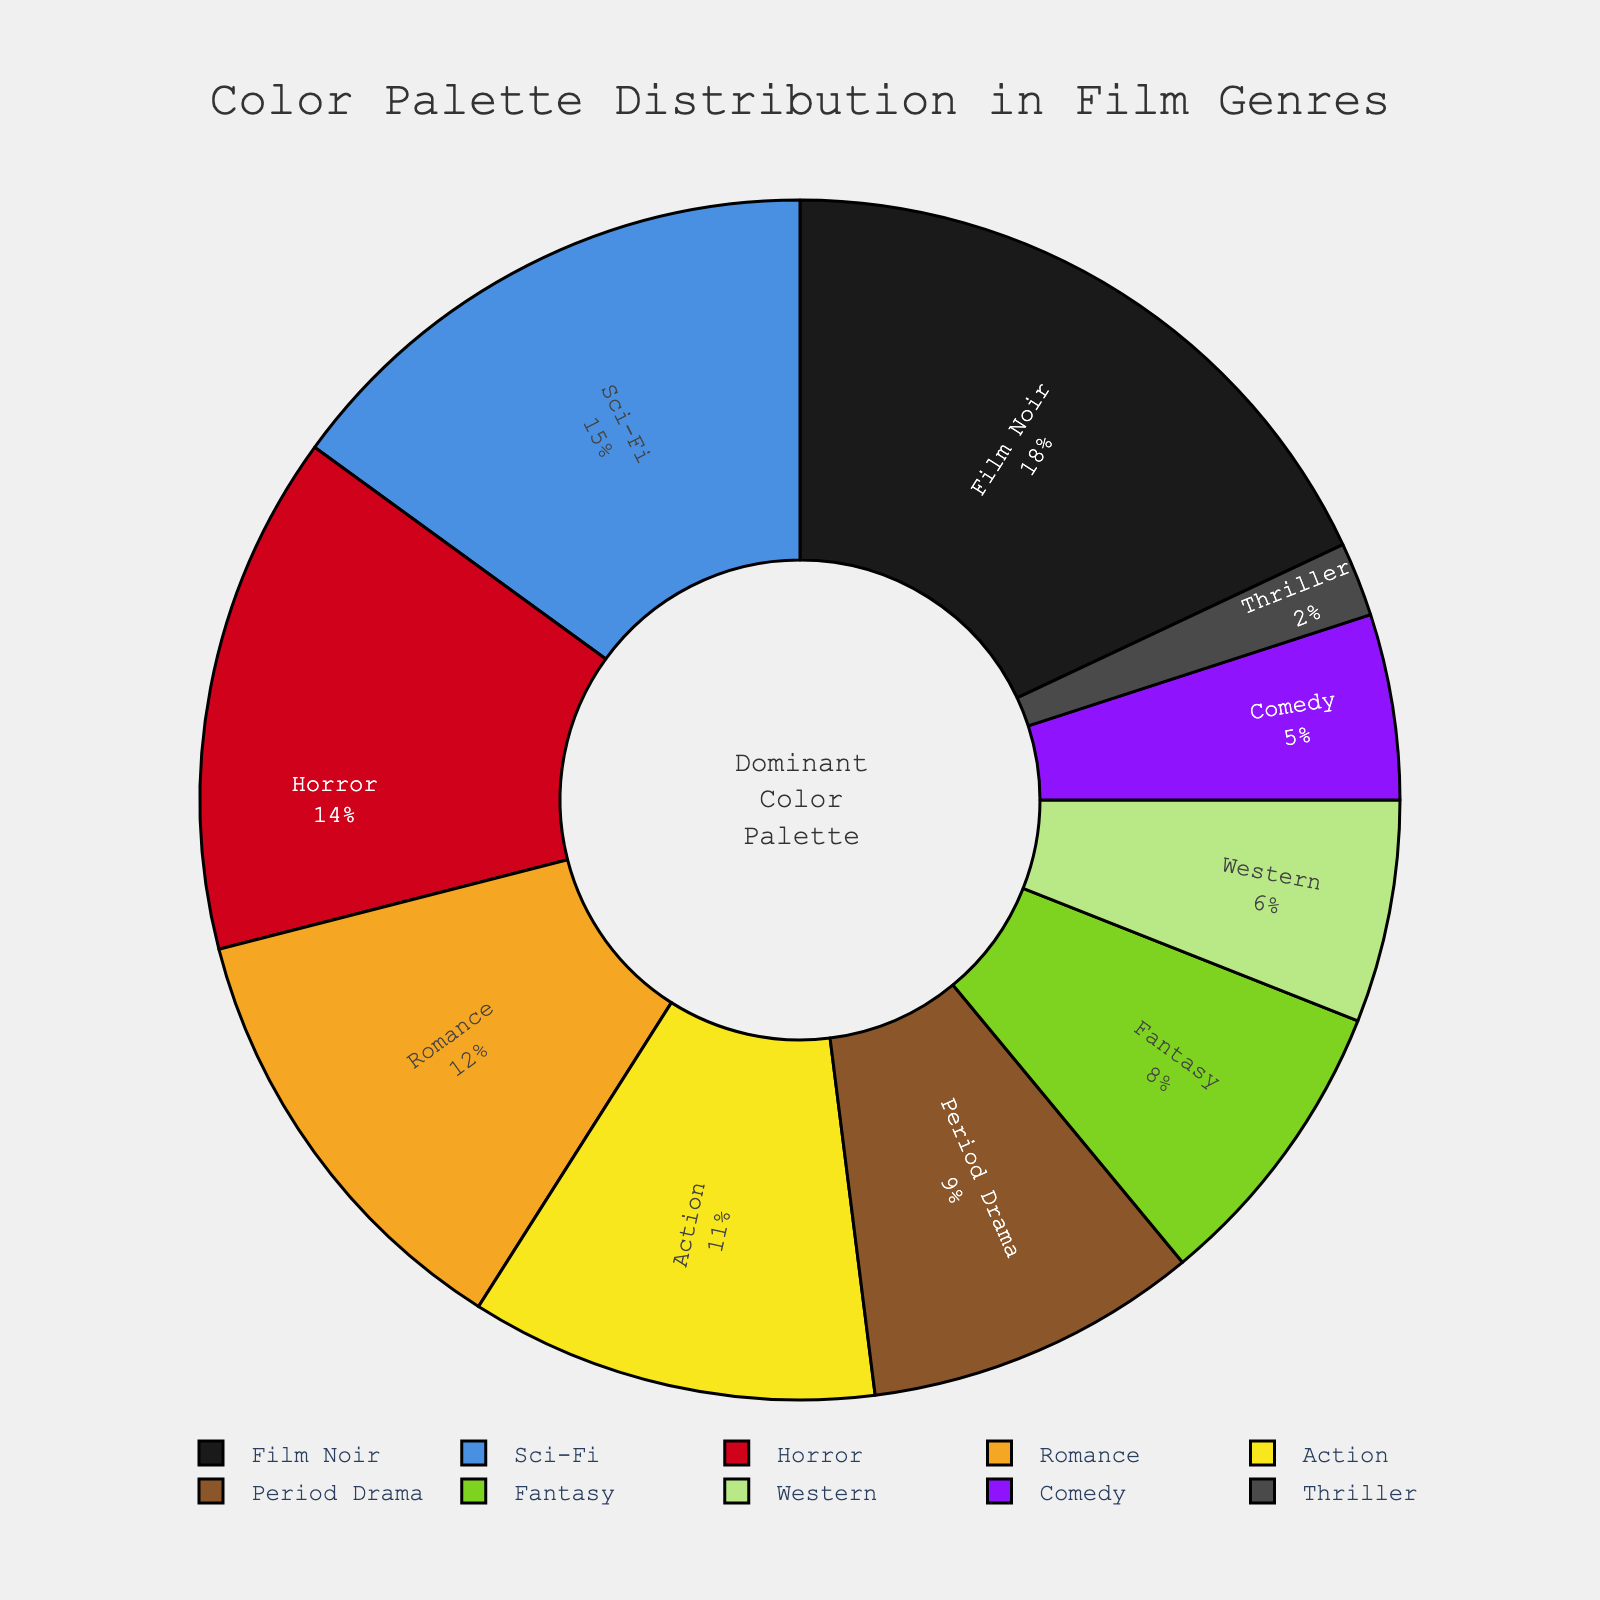What is the most dominant color palette used in film genres? The figure shows different color palettes and their corresponding percentages. The dominant color palette has the highest percentage visually displayed on the plot.
Answer: High Contrast Monochrome Which genre has the smallest proportion of color palettes used? To answer this, look for the genre with the smallest slice in the pie chart, which also has the smallest percentage labeled.
Answer: Thriller What percentage of color palettes used in Romance and Fantasy combined? Sum the percentages of Romantic and Fantasy color palettes, which are 12% and 8% respectively. 12 + 8 = 20
Answer: 20% Is the proportion of color palettes in Action greater than in Western? Compare the percentages of Action (11%) and Western (6%) by checking their labeled values. Since 11 is greater than 6, the answer is yes.
Answer: Yes Which two genres have the closest proportions of color palettes used? Look for the two genres with the closest percentage values on the pie chart. Action (11%) and Period Drama (9%) are the closest. The difference is 2%.
Answer: Action and Period Drama What is the total percentage of color palettes used in the top three genres? Identify the top three genres by percentage (Film Noir, Sci-Fi, Horror). Sum their percentages: 18% + 15% + 14% = 47%
Answer: 47% How does the color palette distribution of Comedy compare to that of Sci-Fi? Compare the percentage values of Comedy (5%) and Sci-Fi (15%). Sci-Fi has a higher proportion than Comedy.
Answer: Sci-Fi has a higher proportion What visual cues are used to represent color palettes of various genres? The pie chart uses different colors for each segment, and the segments are sized according to percentage values with labels indicating genres and percentages.
Answer: Colors and segment sizes with labels What is the difference in color palette usage between Horror and Period Drama? Subtract the percentage of Period Drama from Horror: 14% - 9% = 5%.
Answer: 5% Which genres use a significant portion of color palettes, above 10%? Identify the genres with percentages above 10%. Film Noir (18%), Sci-Fi (15%), Horror (14%), Romance (12%), and Action (11%).
Answer: Film Noir, Sci-Fi, Horror, Romance, Action 